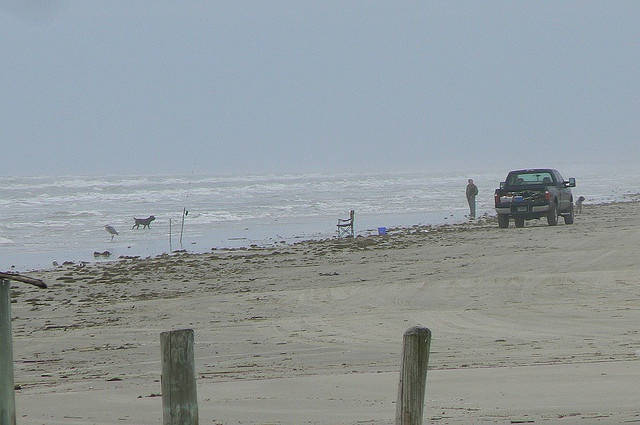Describe the objects in this image and their specific colors. I can see truck in darkgray, gray, black, and purple tones, chair in darkgray and gray tones, people in darkgray, gray, black, and purple tones, dog in darkgray, gray, purple, and black tones, and dog in darkgray and gray tones in this image. 